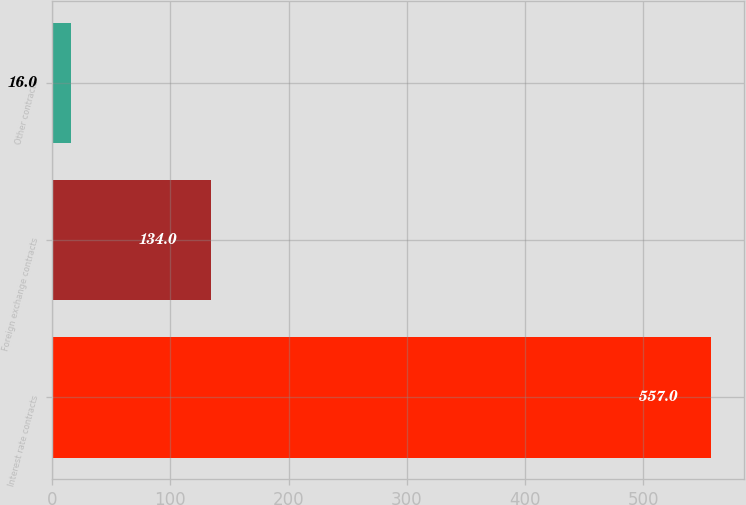Convert chart to OTSL. <chart><loc_0><loc_0><loc_500><loc_500><bar_chart><fcel>Interest rate contracts<fcel>Foreign exchange contracts<fcel>Other contracts<nl><fcel>557<fcel>134<fcel>16<nl></chart> 